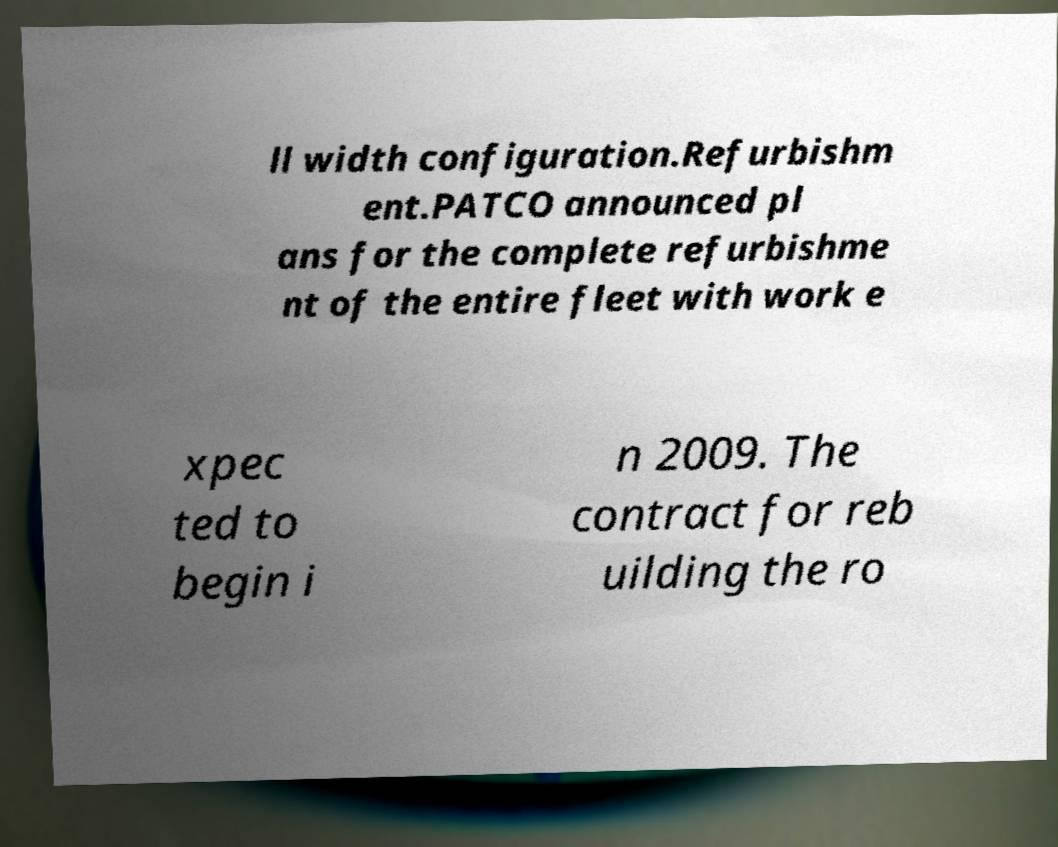For documentation purposes, I need the text within this image transcribed. Could you provide that? ll width configuration.Refurbishm ent.PATCO announced pl ans for the complete refurbishme nt of the entire fleet with work e xpec ted to begin i n 2009. The contract for reb uilding the ro 